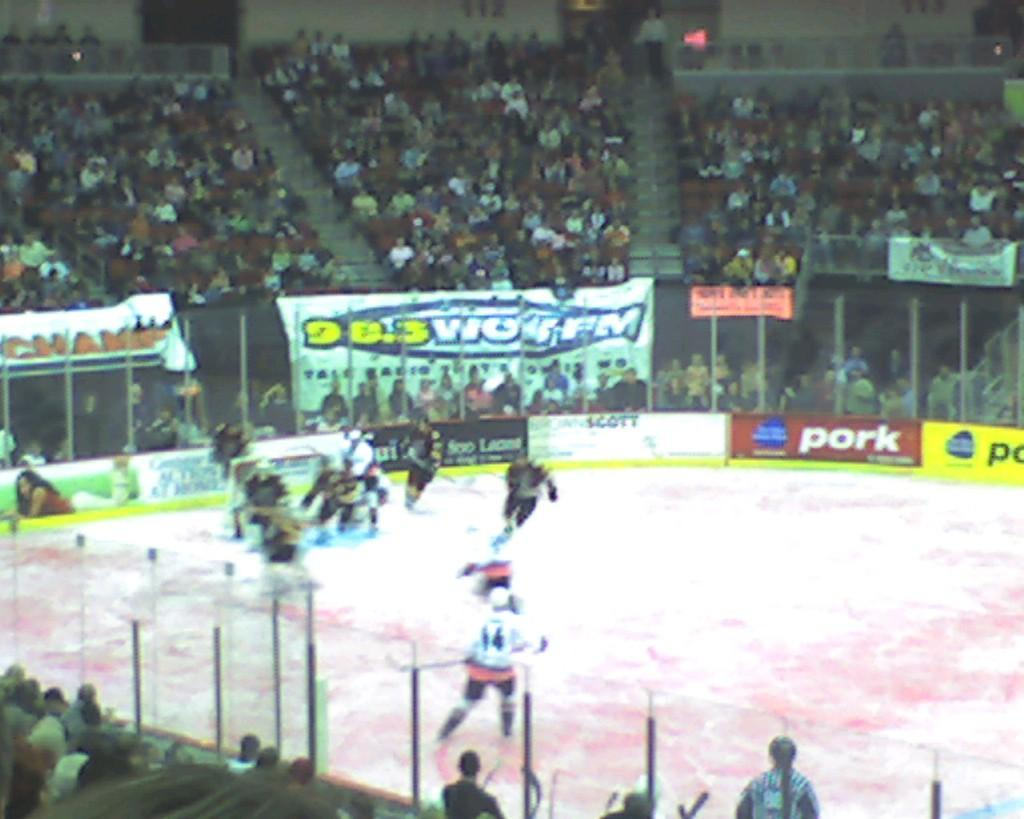<image>
Describe the image concisely. Hockey players skate around ice while spectators watch in an arena with advertisements for pork and 98.3 FM radio. 